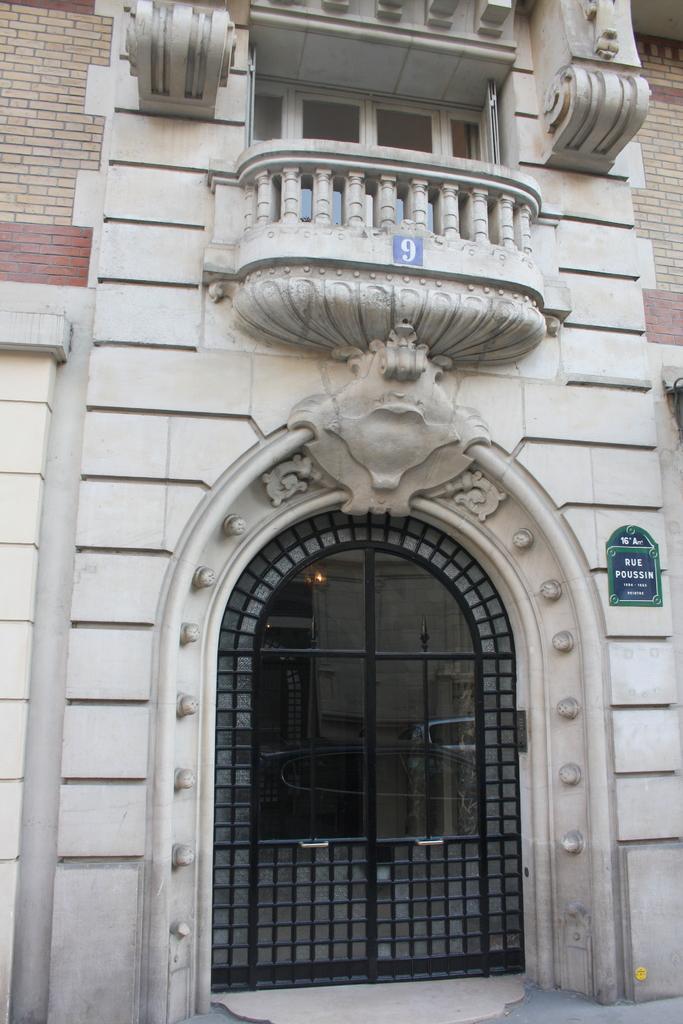Can you describe this image briefly? Picture of a building. To this building there is a door, brick walls and windows. Board is on the wall. 